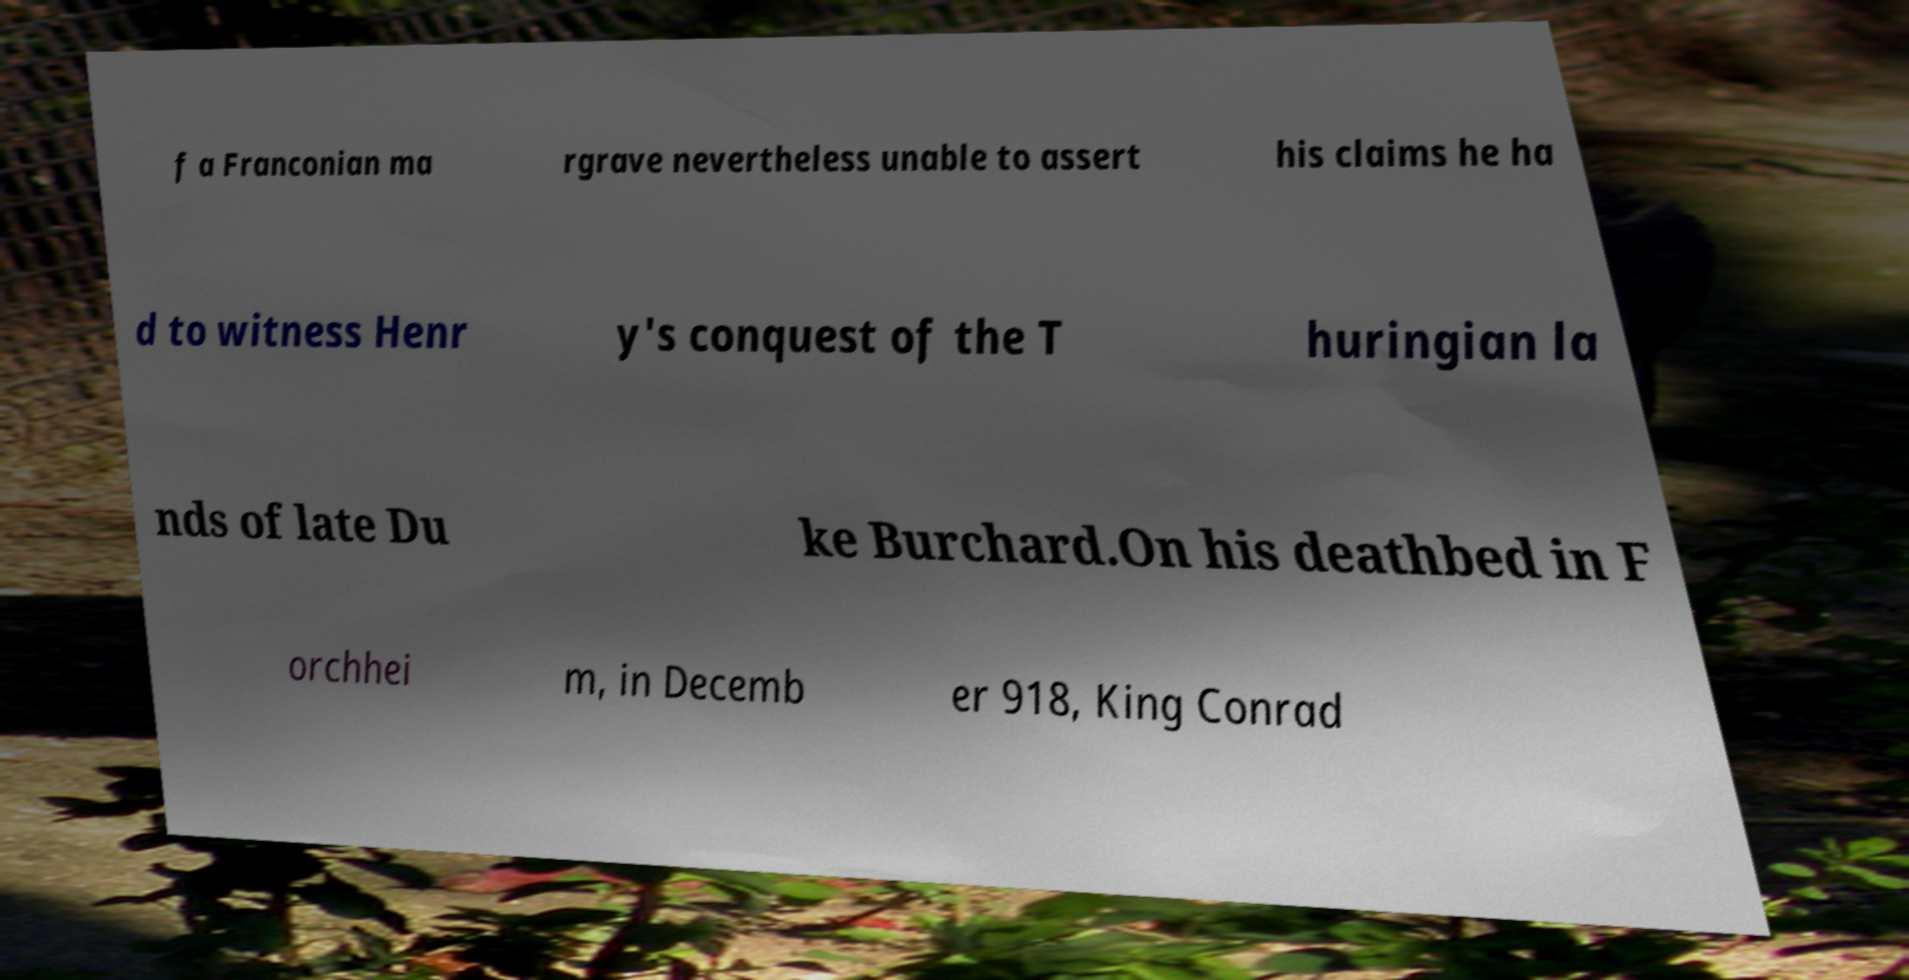Please read and relay the text visible in this image. What does it say? f a Franconian ma rgrave nevertheless unable to assert his claims he ha d to witness Henr y's conquest of the T huringian la nds of late Du ke Burchard.On his deathbed in F orchhei m, in Decemb er 918, King Conrad 